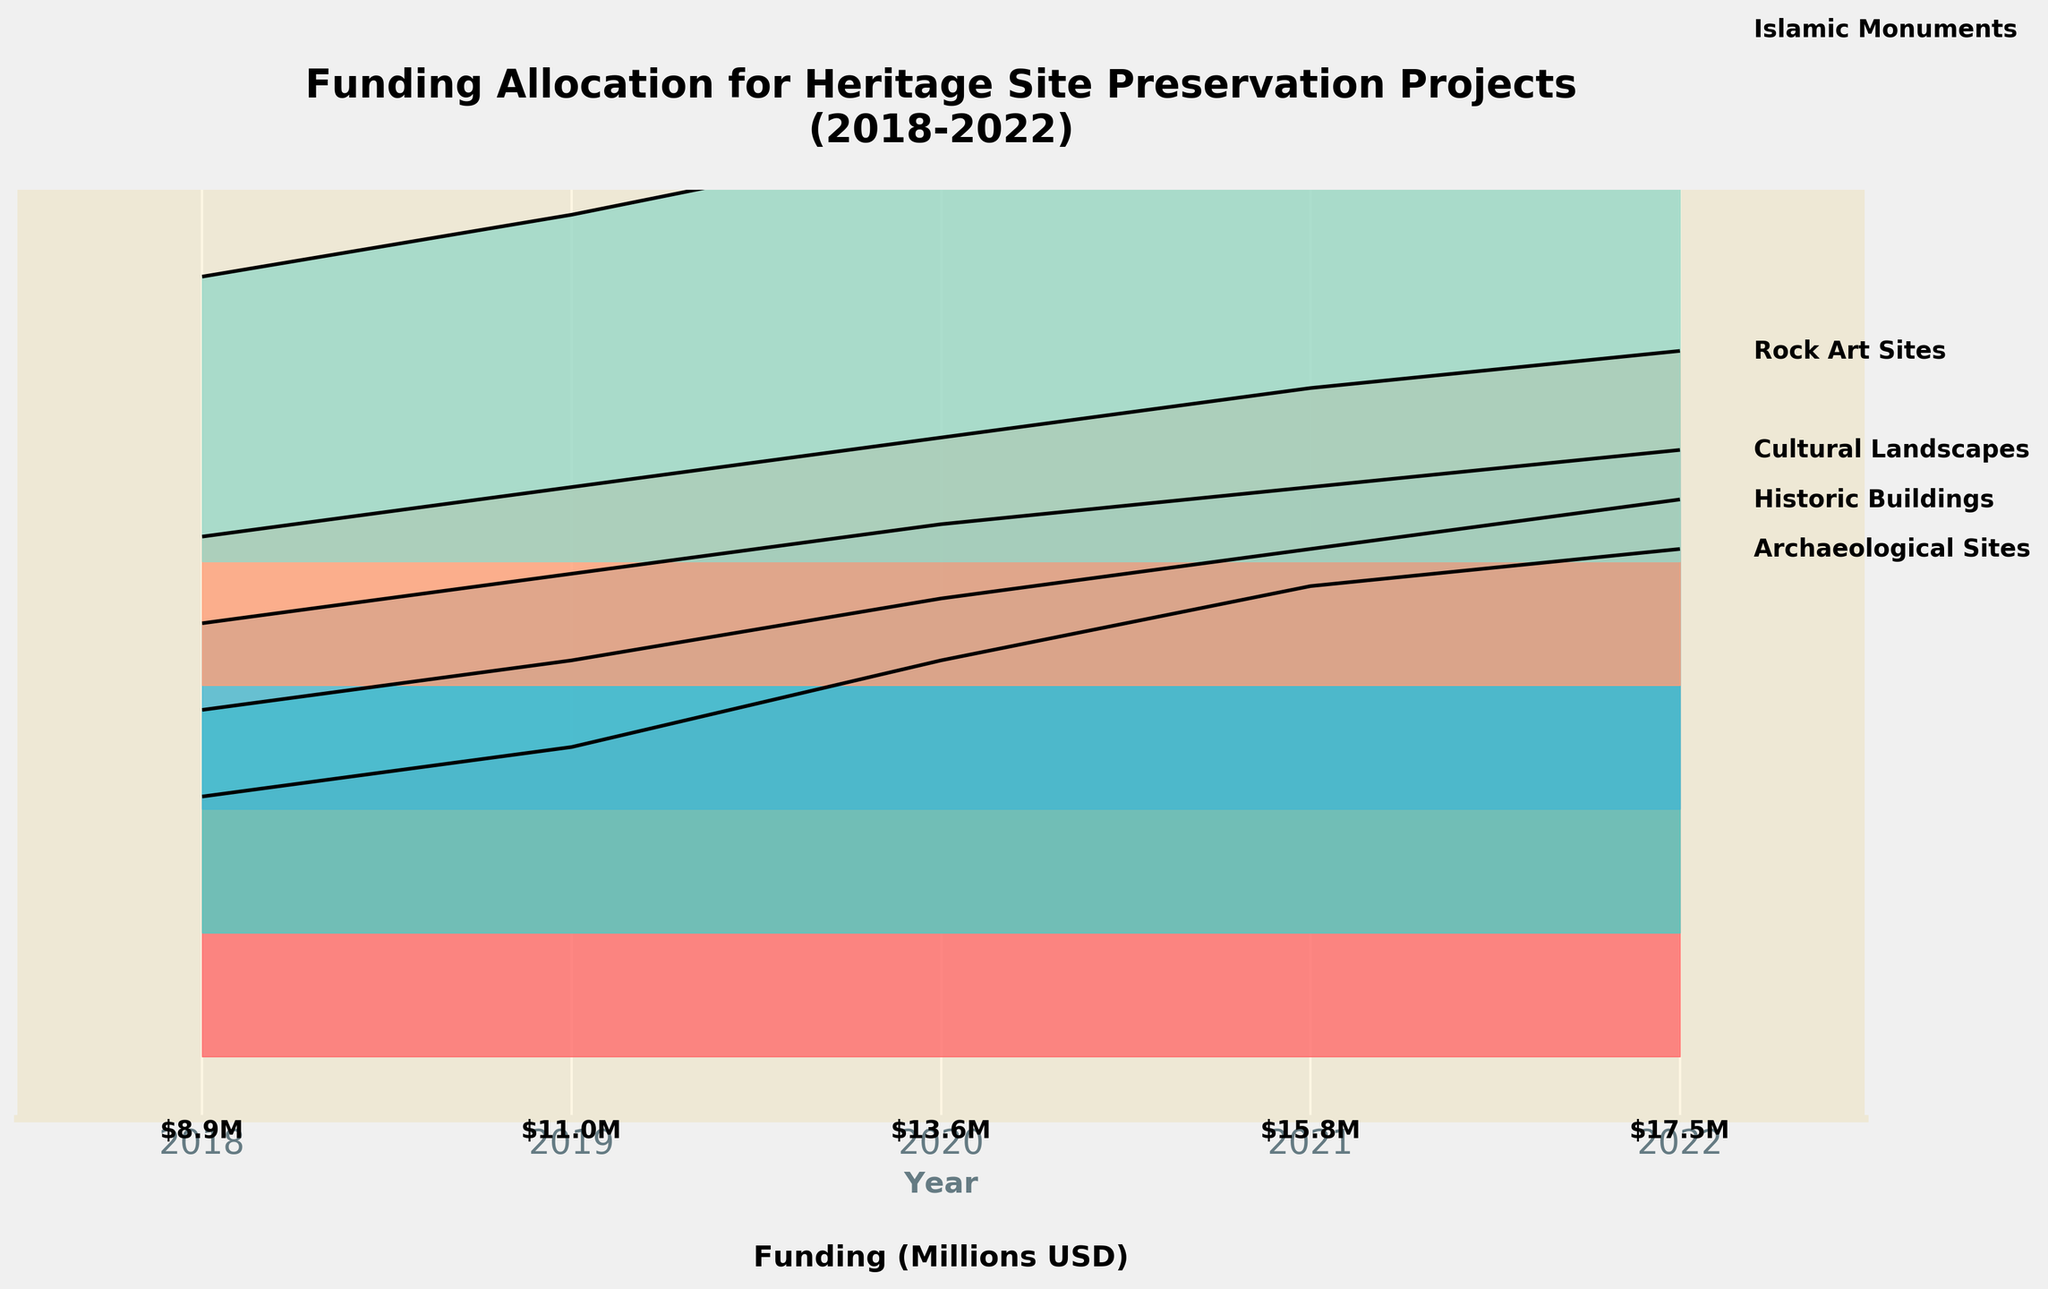What is the title of the figure? The title is prominently displayed at the top of the figure.
Answer: Funding Allocation for Heritage Site Preservation Projects (2018-2022) What is the funding amount for Historic Buildings in 2020? Find the line corresponding to Historic Buildings and locate the year 2020 on the x-axis. Read the y-value at that point.
Answer: 2.7 million USD Which site type received the highest funding in 2022? Compare the funding amounts of all site types in 2022 by looking at the end of the ridgelines.
Answer: Islamic Monuments What is the trend of funding for Archaeological Sites from 2018 to 2022? Follow the line for Archaeological Sites from left (2018) to right (2022) and observe whether it increases, decreases, or remains stable.
Answer: Increases What is the total funding allocation for 2019? Sum the funding amounts of all site types for the year 2019.
Answer: 11 million USD How does the funding for Cultural Landscapes in 2022 compare to 2018? Compare the heights of the funding amounts for Cultural Landscapes in 2022 and 2018.
Answer: Increased Which site type shows the most consistent growth in funding over the years? Identify the lines that show a steady, continuous increase in the y-values from 2018 to 2022.
Answer: Islamic Monuments How do the funding trends for Rock Art Sites and Historic Buildings compare? Compare the lines for both site types over the years 2018 to 2022 and observe their trends.
Answer: Both increase, but Historic Buildings have slightly more funding Approximately how much more funding did Archaeological Sites receive in 2022 compared to 2019? Subtract the funding amount in 2019 from the funding amount in 2022 for Archaeological Sites.
Answer: 1.6 million USD 